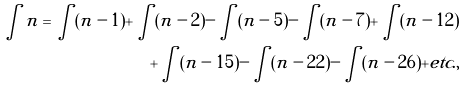<formula> <loc_0><loc_0><loc_500><loc_500>\int n = \int ( n - 1 ) + \int ( n - 2 ) - \int ( n - 5 ) - \int ( n - 7 ) + \int ( n - 1 2 ) \\ + \int ( n - 1 5 ) - \int ( n - 2 2 ) - \int ( n - 2 6 ) + e t c . ,</formula> 